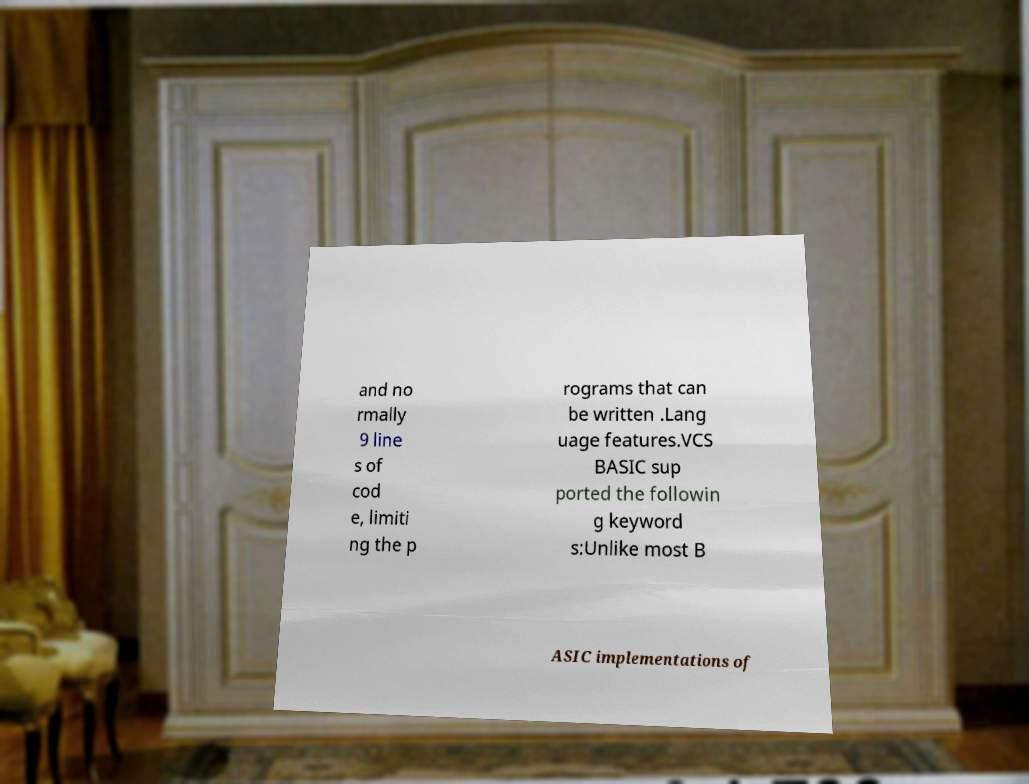There's text embedded in this image that I need extracted. Can you transcribe it verbatim? and no rmally 9 line s of cod e, limiti ng the p rograms that can be written .Lang uage features.VCS BASIC sup ported the followin g keyword s:Unlike most B ASIC implementations of 